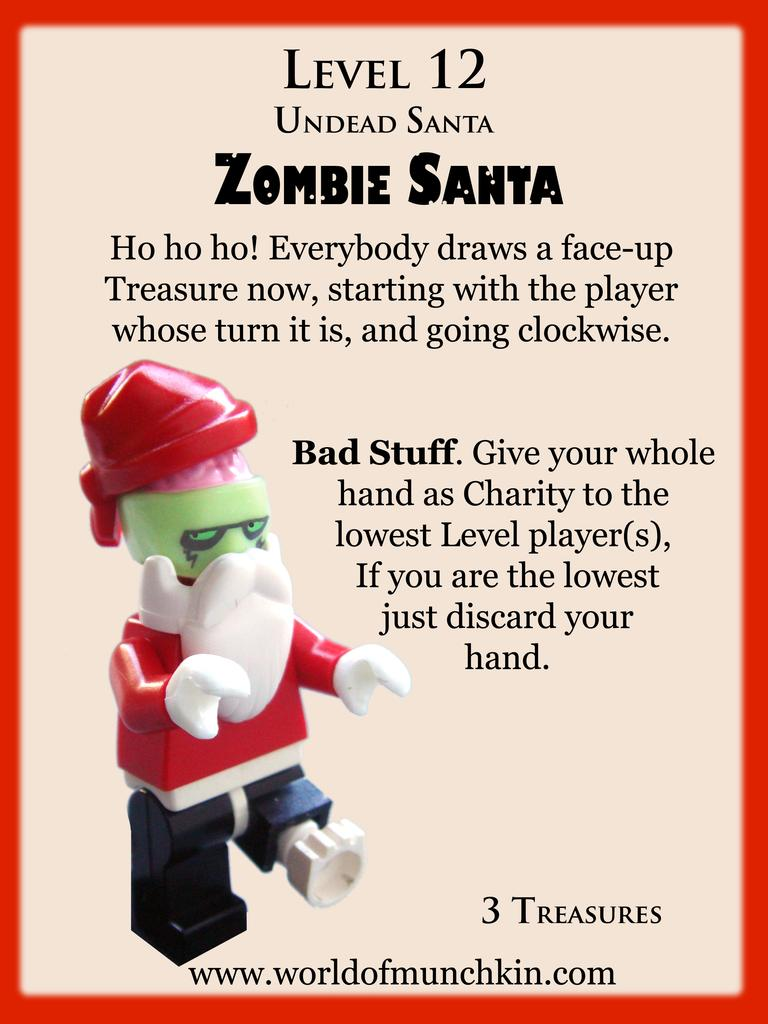What is featured in the image? There is a poster and a toy in the image. What can be seen on the poster? There is writing on the poster. Can you tell me when the toothpaste was last used in the image? There is no toothpaste present in the image, so it is not possible to determine when it was last used. 